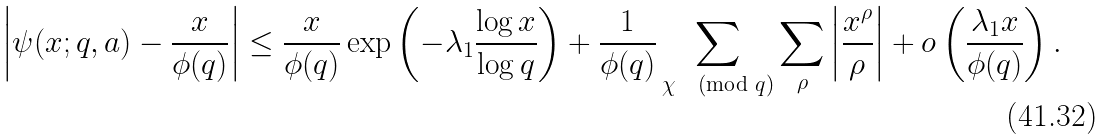Convert formula to latex. <formula><loc_0><loc_0><loc_500><loc_500>\left | \psi ( x ; q , a ) - \frac { x } { \phi ( q ) } \right | \leq \frac { x } { \phi ( q ) } \exp \left ( - \lambda _ { 1 } \frac { \log { x } } { \log { q } } \right ) + \frac { 1 } { \phi ( q ) } \sum _ { \chi \pmod { q } } \sum _ { \rho } \left | \frac { x ^ { \rho } } { \rho } \right | + o \left ( \frac { \lambda _ { 1 } x } { \phi ( q ) } \right ) .</formula> 